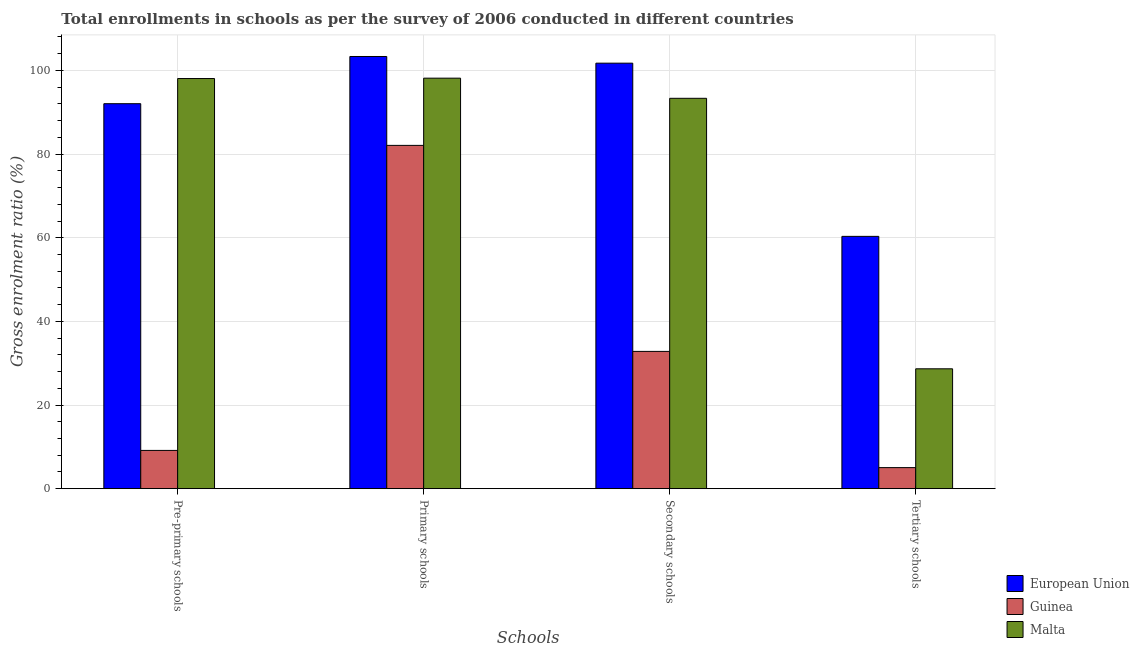How many different coloured bars are there?
Offer a terse response. 3. How many groups of bars are there?
Offer a very short reply. 4. Are the number of bars per tick equal to the number of legend labels?
Your answer should be very brief. Yes. How many bars are there on the 4th tick from the right?
Your answer should be very brief. 3. What is the label of the 1st group of bars from the left?
Your answer should be very brief. Pre-primary schools. What is the gross enrolment ratio in secondary schools in Guinea?
Make the answer very short. 32.82. Across all countries, what is the maximum gross enrolment ratio in pre-primary schools?
Make the answer very short. 98.07. Across all countries, what is the minimum gross enrolment ratio in secondary schools?
Offer a very short reply. 32.82. In which country was the gross enrolment ratio in primary schools maximum?
Your response must be concise. European Union. In which country was the gross enrolment ratio in primary schools minimum?
Keep it short and to the point. Guinea. What is the total gross enrolment ratio in primary schools in the graph?
Provide a succinct answer. 283.58. What is the difference between the gross enrolment ratio in primary schools in Guinea and that in European Union?
Provide a short and direct response. -21.25. What is the difference between the gross enrolment ratio in pre-primary schools in Malta and the gross enrolment ratio in tertiary schools in European Union?
Your response must be concise. 37.74. What is the average gross enrolment ratio in tertiary schools per country?
Make the answer very short. 31.34. What is the difference between the gross enrolment ratio in secondary schools and gross enrolment ratio in pre-primary schools in Malta?
Ensure brevity in your answer.  -4.73. What is the ratio of the gross enrolment ratio in primary schools in Guinea to that in European Union?
Your answer should be very brief. 0.79. Is the gross enrolment ratio in secondary schools in Guinea less than that in Malta?
Offer a very short reply. Yes. Is the difference between the gross enrolment ratio in pre-primary schools in European Union and Malta greater than the difference between the gross enrolment ratio in tertiary schools in European Union and Malta?
Give a very brief answer. No. What is the difference between the highest and the second highest gross enrolment ratio in primary schools?
Offer a very short reply. 5.19. What is the difference between the highest and the lowest gross enrolment ratio in tertiary schools?
Your answer should be very brief. 55.29. In how many countries, is the gross enrolment ratio in secondary schools greater than the average gross enrolment ratio in secondary schools taken over all countries?
Offer a terse response. 2. Is the sum of the gross enrolment ratio in secondary schools in Malta and Guinea greater than the maximum gross enrolment ratio in pre-primary schools across all countries?
Keep it short and to the point. Yes. What does the 1st bar from the left in Pre-primary schools represents?
Your answer should be compact. European Union. What does the 1st bar from the right in Primary schools represents?
Provide a short and direct response. Malta. Is it the case that in every country, the sum of the gross enrolment ratio in pre-primary schools and gross enrolment ratio in primary schools is greater than the gross enrolment ratio in secondary schools?
Provide a short and direct response. Yes. What is the difference between two consecutive major ticks on the Y-axis?
Keep it short and to the point. 20. Where does the legend appear in the graph?
Make the answer very short. Bottom right. How many legend labels are there?
Keep it short and to the point. 3. How are the legend labels stacked?
Ensure brevity in your answer.  Vertical. What is the title of the graph?
Make the answer very short. Total enrollments in schools as per the survey of 2006 conducted in different countries. Does "Cambodia" appear as one of the legend labels in the graph?
Your answer should be compact. No. What is the label or title of the X-axis?
Make the answer very short. Schools. What is the Gross enrolment ratio (%) in European Union in Pre-primary schools?
Your answer should be compact. 92.05. What is the Gross enrolment ratio (%) of Guinea in Pre-primary schools?
Make the answer very short. 9.15. What is the Gross enrolment ratio (%) in Malta in Pre-primary schools?
Provide a succinct answer. 98.07. What is the Gross enrolment ratio (%) in European Union in Primary schools?
Keep it short and to the point. 103.34. What is the Gross enrolment ratio (%) of Guinea in Primary schools?
Provide a short and direct response. 82.08. What is the Gross enrolment ratio (%) of Malta in Primary schools?
Offer a very short reply. 98.15. What is the Gross enrolment ratio (%) of European Union in Secondary schools?
Ensure brevity in your answer.  101.74. What is the Gross enrolment ratio (%) in Guinea in Secondary schools?
Ensure brevity in your answer.  32.82. What is the Gross enrolment ratio (%) of Malta in Secondary schools?
Your answer should be very brief. 93.34. What is the Gross enrolment ratio (%) of European Union in Tertiary schools?
Provide a succinct answer. 60.33. What is the Gross enrolment ratio (%) in Guinea in Tertiary schools?
Keep it short and to the point. 5.04. What is the Gross enrolment ratio (%) of Malta in Tertiary schools?
Keep it short and to the point. 28.66. Across all Schools, what is the maximum Gross enrolment ratio (%) in European Union?
Keep it short and to the point. 103.34. Across all Schools, what is the maximum Gross enrolment ratio (%) of Guinea?
Keep it short and to the point. 82.08. Across all Schools, what is the maximum Gross enrolment ratio (%) in Malta?
Offer a very short reply. 98.15. Across all Schools, what is the minimum Gross enrolment ratio (%) in European Union?
Your answer should be compact. 60.33. Across all Schools, what is the minimum Gross enrolment ratio (%) of Guinea?
Offer a terse response. 5.04. Across all Schools, what is the minimum Gross enrolment ratio (%) of Malta?
Your answer should be very brief. 28.66. What is the total Gross enrolment ratio (%) of European Union in the graph?
Your answer should be very brief. 357.46. What is the total Gross enrolment ratio (%) of Guinea in the graph?
Ensure brevity in your answer.  129.09. What is the total Gross enrolment ratio (%) of Malta in the graph?
Provide a short and direct response. 318.22. What is the difference between the Gross enrolment ratio (%) of European Union in Pre-primary schools and that in Primary schools?
Provide a succinct answer. -11.29. What is the difference between the Gross enrolment ratio (%) in Guinea in Pre-primary schools and that in Primary schools?
Offer a terse response. -72.94. What is the difference between the Gross enrolment ratio (%) in Malta in Pre-primary schools and that in Primary schools?
Offer a terse response. -0.09. What is the difference between the Gross enrolment ratio (%) in European Union in Pre-primary schools and that in Secondary schools?
Provide a short and direct response. -9.69. What is the difference between the Gross enrolment ratio (%) in Guinea in Pre-primary schools and that in Secondary schools?
Ensure brevity in your answer.  -23.68. What is the difference between the Gross enrolment ratio (%) in Malta in Pre-primary schools and that in Secondary schools?
Provide a short and direct response. 4.73. What is the difference between the Gross enrolment ratio (%) of European Union in Pre-primary schools and that in Tertiary schools?
Your answer should be compact. 31.72. What is the difference between the Gross enrolment ratio (%) in Guinea in Pre-primary schools and that in Tertiary schools?
Provide a short and direct response. 4.11. What is the difference between the Gross enrolment ratio (%) of Malta in Pre-primary schools and that in Tertiary schools?
Ensure brevity in your answer.  69.4. What is the difference between the Gross enrolment ratio (%) of European Union in Primary schools and that in Secondary schools?
Your response must be concise. 1.6. What is the difference between the Gross enrolment ratio (%) of Guinea in Primary schools and that in Secondary schools?
Your answer should be compact. 49.26. What is the difference between the Gross enrolment ratio (%) in Malta in Primary schools and that in Secondary schools?
Give a very brief answer. 4.82. What is the difference between the Gross enrolment ratio (%) in European Union in Primary schools and that in Tertiary schools?
Your answer should be compact. 43.01. What is the difference between the Gross enrolment ratio (%) in Guinea in Primary schools and that in Tertiary schools?
Give a very brief answer. 77.05. What is the difference between the Gross enrolment ratio (%) in Malta in Primary schools and that in Tertiary schools?
Keep it short and to the point. 69.49. What is the difference between the Gross enrolment ratio (%) in European Union in Secondary schools and that in Tertiary schools?
Your response must be concise. 41.41. What is the difference between the Gross enrolment ratio (%) of Guinea in Secondary schools and that in Tertiary schools?
Your answer should be very brief. 27.79. What is the difference between the Gross enrolment ratio (%) of Malta in Secondary schools and that in Tertiary schools?
Give a very brief answer. 64.68. What is the difference between the Gross enrolment ratio (%) in European Union in Pre-primary schools and the Gross enrolment ratio (%) in Guinea in Primary schools?
Make the answer very short. 9.97. What is the difference between the Gross enrolment ratio (%) in European Union in Pre-primary schools and the Gross enrolment ratio (%) in Malta in Primary schools?
Provide a succinct answer. -6.1. What is the difference between the Gross enrolment ratio (%) of Guinea in Pre-primary schools and the Gross enrolment ratio (%) of Malta in Primary schools?
Make the answer very short. -89.01. What is the difference between the Gross enrolment ratio (%) in European Union in Pre-primary schools and the Gross enrolment ratio (%) in Guinea in Secondary schools?
Provide a succinct answer. 59.23. What is the difference between the Gross enrolment ratio (%) in European Union in Pre-primary schools and the Gross enrolment ratio (%) in Malta in Secondary schools?
Your answer should be very brief. -1.29. What is the difference between the Gross enrolment ratio (%) in Guinea in Pre-primary schools and the Gross enrolment ratio (%) in Malta in Secondary schools?
Provide a succinct answer. -84.19. What is the difference between the Gross enrolment ratio (%) of European Union in Pre-primary schools and the Gross enrolment ratio (%) of Guinea in Tertiary schools?
Provide a succinct answer. 87.02. What is the difference between the Gross enrolment ratio (%) in European Union in Pre-primary schools and the Gross enrolment ratio (%) in Malta in Tertiary schools?
Offer a terse response. 63.39. What is the difference between the Gross enrolment ratio (%) of Guinea in Pre-primary schools and the Gross enrolment ratio (%) of Malta in Tertiary schools?
Give a very brief answer. -19.52. What is the difference between the Gross enrolment ratio (%) in European Union in Primary schools and the Gross enrolment ratio (%) in Guinea in Secondary schools?
Your answer should be compact. 70.52. What is the difference between the Gross enrolment ratio (%) in European Union in Primary schools and the Gross enrolment ratio (%) in Malta in Secondary schools?
Offer a terse response. 10. What is the difference between the Gross enrolment ratio (%) in Guinea in Primary schools and the Gross enrolment ratio (%) in Malta in Secondary schools?
Your answer should be very brief. -11.25. What is the difference between the Gross enrolment ratio (%) of European Union in Primary schools and the Gross enrolment ratio (%) of Guinea in Tertiary schools?
Your answer should be compact. 98.3. What is the difference between the Gross enrolment ratio (%) in European Union in Primary schools and the Gross enrolment ratio (%) in Malta in Tertiary schools?
Your response must be concise. 74.68. What is the difference between the Gross enrolment ratio (%) in Guinea in Primary schools and the Gross enrolment ratio (%) in Malta in Tertiary schools?
Give a very brief answer. 53.42. What is the difference between the Gross enrolment ratio (%) in European Union in Secondary schools and the Gross enrolment ratio (%) in Guinea in Tertiary schools?
Your response must be concise. 96.7. What is the difference between the Gross enrolment ratio (%) in European Union in Secondary schools and the Gross enrolment ratio (%) in Malta in Tertiary schools?
Your response must be concise. 73.08. What is the difference between the Gross enrolment ratio (%) of Guinea in Secondary schools and the Gross enrolment ratio (%) of Malta in Tertiary schools?
Your answer should be very brief. 4.16. What is the average Gross enrolment ratio (%) of European Union per Schools?
Keep it short and to the point. 89.37. What is the average Gross enrolment ratio (%) of Guinea per Schools?
Ensure brevity in your answer.  32.27. What is the average Gross enrolment ratio (%) in Malta per Schools?
Give a very brief answer. 79.55. What is the difference between the Gross enrolment ratio (%) in European Union and Gross enrolment ratio (%) in Guinea in Pre-primary schools?
Offer a very short reply. 82.91. What is the difference between the Gross enrolment ratio (%) in European Union and Gross enrolment ratio (%) in Malta in Pre-primary schools?
Your answer should be compact. -6.01. What is the difference between the Gross enrolment ratio (%) of Guinea and Gross enrolment ratio (%) of Malta in Pre-primary schools?
Keep it short and to the point. -88.92. What is the difference between the Gross enrolment ratio (%) of European Union and Gross enrolment ratio (%) of Guinea in Primary schools?
Your response must be concise. 21.25. What is the difference between the Gross enrolment ratio (%) in European Union and Gross enrolment ratio (%) in Malta in Primary schools?
Provide a short and direct response. 5.18. What is the difference between the Gross enrolment ratio (%) of Guinea and Gross enrolment ratio (%) of Malta in Primary schools?
Offer a very short reply. -16.07. What is the difference between the Gross enrolment ratio (%) of European Union and Gross enrolment ratio (%) of Guinea in Secondary schools?
Keep it short and to the point. 68.92. What is the difference between the Gross enrolment ratio (%) in European Union and Gross enrolment ratio (%) in Malta in Secondary schools?
Your answer should be compact. 8.4. What is the difference between the Gross enrolment ratio (%) in Guinea and Gross enrolment ratio (%) in Malta in Secondary schools?
Your answer should be compact. -60.52. What is the difference between the Gross enrolment ratio (%) in European Union and Gross enrolment ratio (%) in Guinea in Tertiary schools?
Your answer should be compact. 55.29. What is the difference between the Gross enrolment ratio (%) of European Union and Gross enrolment ratio (%) of Malta in Tertiary schools?
Make the answer very short. 31.67. What is the difference between the Gross enrolment ratio (%) of Guinea and Gross enrolment ratio (%) of Malta in Tertiary schools?
Ensure brevity in your answer.  -23.63. What is the ratio of the Gross enrolment ratio (%) in European Union in Pre-primary schools to that in Primary schools?
Give a very brief answer. 0.89. What is the ratio of the Gross enrolment ratio (%) in Guinea in Pre-primary schools to that in Primary schools?
Provide a succinct answer. 0.11. What is the ratio of the Gross enrolment ratio (%) in European Union in Pre-primary schools to that in Secondary schools?
Offer a very short reply. 0.9. What is the ratio of the Gross enrolment ratio (%) in Guinea in Pre-primary schools to that in Secondary schools?
Give a very brief answer. 0.28. What is the ratio of the Gross enrolment ratio (%) of Malta in Pre-primary schools to that in Secondary schools?
Your answer should be very brief. 1.05. What is the ratio of the Gross enrolment ratio (%) in European Union in Pre-primary schools to that in Tertiary schools?
Offer a very short reply. 1.53. What is the ratio of the Gross enrolment ratio (%) of Guinea in Pre-primary schools to that in Tertiary schools?
Your answer should be very brief. 1.82. What is the ratio of the Gross enrolment ratio (%) in Malta in Pre-primary schools to that in Tertiary schools?
Make the answer very short. 3.42. What is the ratio of the Gross enrolment ratio (%) of European Union in Primary schools to that in Secondary schools?
Offer a very short reply. 1.02. What is the ratio of the Gross enrolment ratio (%) in Guinea in Primary schools to that in Secondary schools?
Your answer should be very brief. 2.5. What is the ratio of the Gross enrolment ratio (%) in Malta in Primary schools to that in Secondary schools?
Your answer should be compact. 1.05. What is the ratio of the Gross enrolment ratio (%) in European Union in Primary schools to that in Tertiary schools?
Your answer should be very brief. 1.71. What is the ratio of the Gross enrolment ratio (%) of Guinea in Primary schools to that in Tertiary schools?
Offer a very short reply. 16.3. What is the ratio of the Gross enrolment ratio (%) in Malta in Primary schools to that in Tertiary schools?
Make the answer very short. 3.42. What is the ratio of the Gross enrolment ratio (%) in European Union in Secondary schools to that in Tertiary schools?
Offer a very short reply. 1.69. What is the ratio of the Gross enrolment ratio (%) of Guinea in Secondary schools to that in Tertiary schools?
Your answer should be compact. 6.52. What is the ratio of the Gross enrolment ratio (%) in Malta in Secondary schools to that in Tertiary schools?
Give a very brief answer. 3.26. What is the difference between the highest and the second highest Gross enrolment ratio (%) of European Union?
Give a very brief answer. 1.6. What is the difference between the highest and the second highest Gross enrolment ratio (%) of Guinea?
Make the answer very short. 49.26. What is the difference between the highest and the second highest Gross enrolment ratio (%) in Malta?
Your answer should be compact. 0.09. What is the difference between the highest and the lowest Gross enrolment ratio (%) in European Union?
Ensure brevity in your answer.  43.01. What is the difference between the highest and the lowest Gross enrolment ratio (%) in Guinea?
Give a very brief answer. 77.05. What is the difference between the highest and the lowest Gross enrolment ratio (%) in Malta?
Make the answer very short. 69.49. 